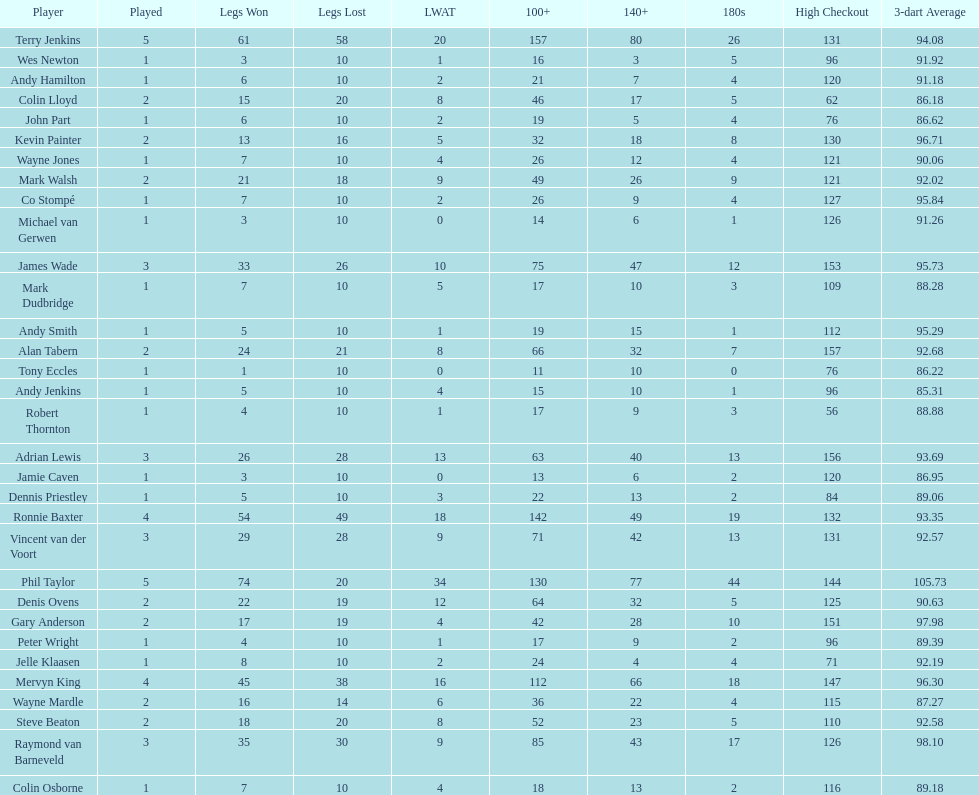Which player lost the least? Co Stompé, Andy Smith, Jelle Klaasen, Wes Newton, Michael van Gerwen, Andy Hamilton, Wayne Jones, Peter Wright, Colin Osborne, Dennis Priestley, Robert Thornton, Mark Dudbridge, Jamie Caven, John Part, Tony Eccles, Andy Jenkins. 